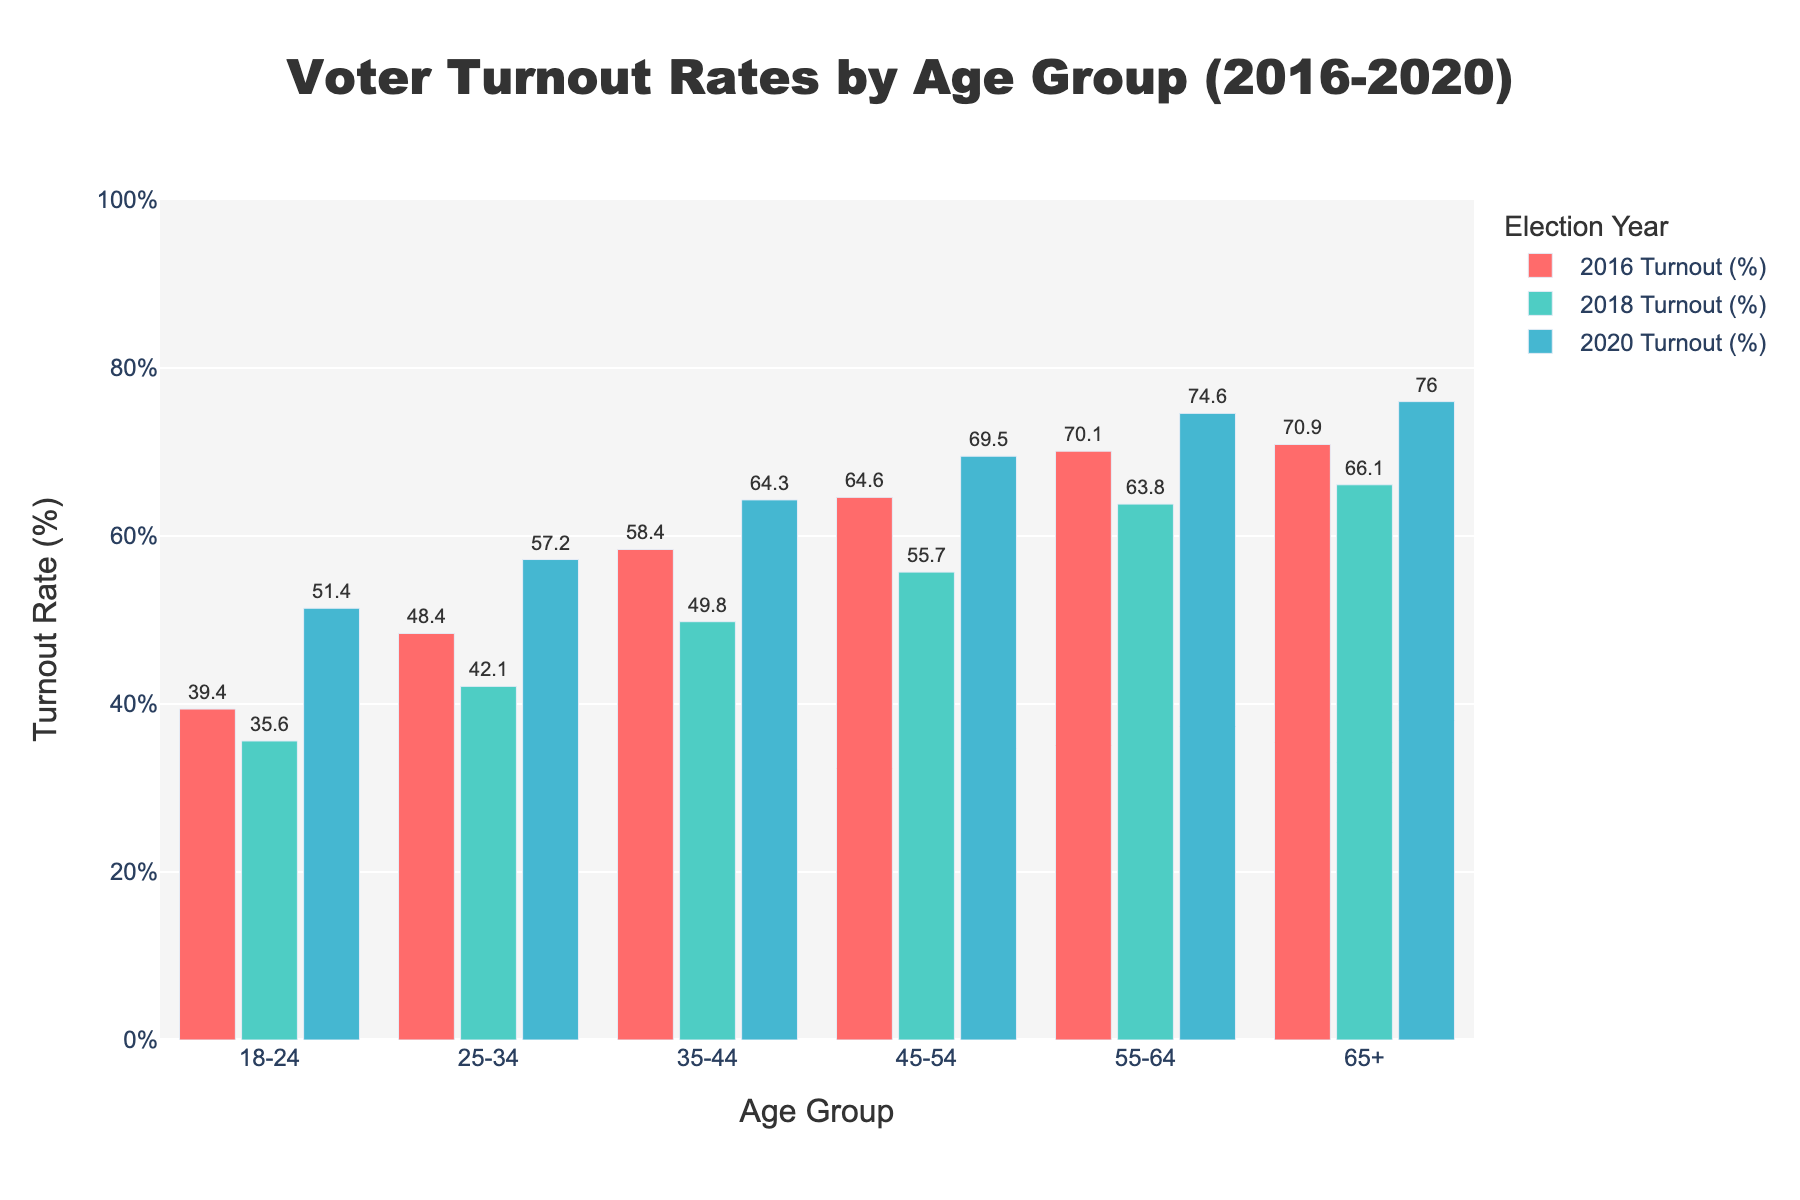What age group experienced the largest increase in voter turnout from 2016 to 2020? First, find the turnout rates for each age group in 2016 and 2020. Then, calculate the difference for each group: "18-24" (51.4 - 39.4 = 12), "25-34" (57.2 - 48.4 = 8.8), "35-44" (64.3 - 58.4 = 5.9), "45-54" (69.5 - 64.6 = 4.9), "55-64" (74.6 - 70.1 = 4.5), "65+" (76.0 - 70.9 = 5.1). The largest increase is 12 for the "18-24" age group.
Answer: 18-24 For which age group did voter turnout decrease between 2016 and 2018? Compare the turnout rates in 2016 and 2018 for each age group: "18-24" (35.6 < 39.4), "25-34" (42.1 < 48.4), "35-44" (49.8 < 58.4), "45-54" (55.7 < 64.6), "55-64" (63.8 < 70.1), "65+" (66.1 < 70.9). All age groups experienced a decrease in turnout from 2016 to 2018.
Answer: All age groups What is the difference in voter turnout rate between the youngest and oldest age groups in 2020? Identify the turnout rates for "18-24" (51.4) and "65+" (76.0) in 2020. Subtract the turnout rate for "18-24" from "65+" to find the difference (76.0 - 51.4 = 24.6).
Answer: 24.6 Which age group had the highest voter turnout in 2018? Identify the turnout rates for each age group in 2018: "18-24" (35.6), "25-34" (42.1), "35-44" (49.8), "45-54" (55.7), "55-64" (63.8), "65+" (66.1). The "65+" age group had the highest turnout.
Answer: 65+ How much higher was the voter turnout for the "55-64" age group compared to the "35-44" age group in 2016? Identify the turnout rates for "55-64" (70.1) and "35-44" (58.4) in 2016. Subtract the turnout rate for "35-44" from "55-64" to find the difference (70.1 - 58.4 = 11.7).
Answer: 11.7 What was the average voter turnout rate for all age groups in 2020? Find the turnout rates in 2020 for all age groups: "18-24" (51.4), "25-34" (57.2), "35-44" (64.3), "45-54" (69.5), "55-64" (74.6), "65+" (76.0). Sum these rates (51.4 + 57.2 + 64.3 + 69.5 + 74.6 + 76.0 = 393). Divide by the number of groups (393 / 6 = 65.5).
Answer: 65.5 Between 2016 and 2020, which two age groups had the closest voter turnout rates in any election year? Compare the turnout rates for 2016, 2018, and 2020 and identify pairs with minimal difference: 2016 ("55-64" 70.1, "65+" 70.9, difference = 0.8), 2018 ("45-54" 55.7, "55-64" 63.8, difference = 8.1), 2020 ("25-34" 57.2, "35-44" 64.3, difference = 7.1). The closest turnout rates were in 2016 between "55-64" and "65+".
Answer: 55-64 and 65+ in 2016 